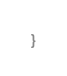Convert code to text. <code><loc_0><loc_0><loc_500><loc_500><_C++_>}
</code> 